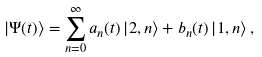Convert formula to latex. <formula><loc_0><loc_0><loc_500><loc_500>\left | \Psi ( t ) \right > = \sum _ { n = 0 } ^ { \infty } a _ { n } ( t ) \left | 2 , n \right > + b _ { n } ( t ) \left | 1 , n \right > ,</formula> 